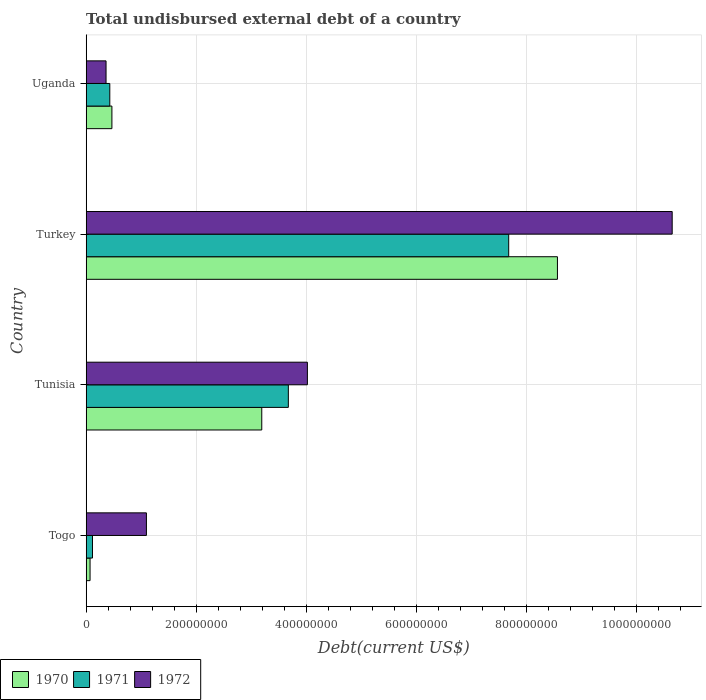How many groups of bars are there?
Keep it short and to the point. 4. Are the number of bars per tick equal to the number of legend labels?
Offer a terse response. Yes. Are the number of bars on each tick of the Y-axis equal?
Offer a very short reply. Yes. How many bars are there on the 3rd tick from the bottom?
Offer a very short reply. 3. What is the label of the 4th group of bars from the top?
Ensure brevity in your answer.  Togo. In how many cases, is the number of bars for a given country not equal to the number of legend labels?
Your answer should be compact. 0. What is the total undisbursed external debt in 1970 in Togo?
Your answer should be compact. 7.03e+06. Across all countries, what is the maximum total undisbursed external debt in 1971?
Your response must be concise. 7.68e+08. Across all countries, what is the minimum total undisbursed external debt in 1970?
Offer a very short reply. 7.03e+06. In which country was the total undisbursed external debt in 1972 minimum?
Keep it short and to the point. Uganda. What is the total total undisbursed external debt in 1970 in the graph?
Your response must be concise. 1.23e+09. What is the difference between the total undisbursed external debt in 1970 in Togo and that in Turkey?
Ensure brevity in your answer.  -8.50e+08. What is the difference between the total undisbursed external debt in 1971 in Uganda and the total undisbursed external debt in 1970 in Turkey?
Ensure brevity in your answer.  -8.14e+08. What is the average total undisbursed external debt in 1971 per country?
Offer a terse response. 2.98e+08. What is the difference between the total undisbursed external debt in 1970 and total undisbursed external debt in 1972 in Togo?
Give a very brief answer. -1.02e+08. What is the ratio of the total undisbursed external debt in 1971 in Togo to that in Turkey?
Offer a terse response. 0.01. What is the difference between the highest and the second highest total undisbursed external debt in 1970?
Give a very brief answer. 5.38e+08. What is the difference between the highest and the lowest total undisbursed external debt in 1971?
Make the answer very short. 7.57e+08. In how many countries, is the total undisbursed external debt in 1971 greater than the average total undisbursed external debt in 1971 taken over all countries?
Your answer should be compact. 2. What does the 2nd bar from the top in Tunisia represents?
Offer a terse response. 1971. What does the 3rd bar from the bottom in Uganda represents?
Keep it short and to the point. 1972. Are all the bars in the graph horizontal?
Ensure brevity in your answer.  Yes. Does the graph contain grids?
Make the answer very short. Yes. Where does the legend appear in the graph?
Provide a succinct answer. Bottom left. How are the legend labels stacked?
Give a very brief answer. Horizontal. What is the title of the graph?
Your answer should be very brief. Total undisbursed external debt of a country. Does "2015" appear as one of the legend labels in the graph?
Your answer should be compact. No. What is the label or title of the X-axis?
Your answer should be very brief. Debt(current US$). What is the label or title of the Y-axis?
Ensure brevity in your answer.  Country. What is the Debt(current US$) of 1970 in Togo?
Offer a terse response. 7.03e+06. What is the Debt(current US$) of 1971 in Togo?
Your answer should be compact. 1.15e+07. What is the Debt(current US$) in 1972 in Togo?
Provide a short and direct response. 1.10e+08. What is the Debt(current US$) of 1970 in Tunisia?
Ensure brevity in your answer.  3.19e+08. What is the Debt(current US$) of 1971 in Tunisia?
Ensure brevity in your answer.  3.68e+08. What is the Debt(current US$) in 1972 in Tunisia?
Give a very brief answer. 4.02e+08. What is the Debt(current US$) in 1970 in Turkey?
Make the answer very short. 8.57e+08. What is the Debt(current US$) in 1971 in Turkey?
Offer a terse response. 7.68e+08. What is the Debt(current US$) of 1972 in Turkey?
Your response must be concise. 1.07e+09. What is the Debt(current US$) of 1970 in Uganda?
Your response must be concise. 4.68e+07. What is the Debt(current US$) of 1971 in Uganda?
Give a very brief answer. 4.29e+07. What is the Debt(current US$) of 1972 in Uganda?
Offer a terse response. 3.61e+07. Across all countries, what is the maximum Debt(current US$) in 1970?
Offer a terse response. 8.57e+08. Across all countries, what is the maximum Debt(current US$) in 1971?
Provide a succinct answer. 7.68e+08. Across all countries, what is the maximum Debt(current US$) in 1972?
Your answer should be compact. 1.07e+09. Across all countries, what is the minimum Debt(current US$) in 1970?
Make the answer very short. 7.03e+06. Across all countries, what is the minimum Debt(current US$) of 1971?
Offer a terse response. 1.15e+07. Across all countries, what is the minimum Debt(current US$) of 1972?
Give a very brief answer. 3.61e+07. What is the total Debt(current US$) of 1970 in the graph?
Offer a very short reply. 1.23e+09. What is the total Debt(current US$) in 1971 in the graph?
Provide a short and direct response. 1.19e+09. What is the total Debt(current US$) of 1972 in the graph?
Keep it short and to the point. 1.61e+09. What is the difference between the Debt(current US$) of 1970 in Togo and that in Tunisia?
Provide a short and direct response. -3.12e+08. What is the difference between the Debt(current US$) of 1971 in Togo and that in Tunisia?
Give a very brief answer. -3.56e+08. What is the difference between the Debt(current US$) of 1972 in Togo and that in Tunisia?
Keep it short and to the point. -2.93e+08. What is the difference between the Debt(current US$) in 1970 in Togo and that in Turkey?
Your answer should be very brief. -8.50e+08. What is the difference between the Debt(current US$) of 1971 in Togo and that in Turkey?
Provide a succinct answer. -7.57e+08. What is the difference between the Debt(current US$) in 1972 in Togo and that in Turkey?
Offer a very short reply. -9.56e+08. What is the difference between the Debt(current US$) of 1970 in Togo and that in Uganda?
Offer a terse response. -3.97e+07. What is the difference between the Debt(current US$) in 1971 in Togo and that in Uganda?
Provide a short and direct response. -3.15e+07. What is the difference between the Debt(current US$) in 1972 in Togo and that in Uganda?
Offer a terse response. 7.34e+07. What is the difference between the Debt(current US$) in 1970 in Tunisia and that in Turkey?
Your response must be concise. -5.38e+08. What is the difference between the Debt(current US$) in 1971 in Tunisia and that in Turkey?
Provide a succinct answer. -4.01e+08. What is the difference between the Debt(current US$) in 1972 in Tunisia and that in Turkey?
Make the answer very short. -6.63e+08. What is the difference between the Debt(current US$) of 1970 in Tunisia and that in Uganda?
Ensure brevity in your answer.  2.72e+08. What is the difference between the Debt(current US$) of 1971 in Tunisia and that in Uganda?
Offer a very short reply. 3.25e+08. What is the difference between the Debt(current US$) of 1972 in Tunisia and that in Uganda?
Keep it short and to the point. 3.66e+08. What is the difference between the Debt(current US$) of 1970 in Turkey and that in Uganda?
Provide a succinct answer. 8.10e+08. What is the difference between the Debt(current US$) in 1971 in Turkey and that in Uganda?
Offer a terse response. 7.25e+08. What is the difference between the Debt(current US$) of 1972 in Turkey and that in Uganda?
Make the answer very short. 1.03e+09. What is the difference between the Debt(current US$) of 1970 in Togo and the Debt(current US$) of 1971 in Tunisia?
Your response must be concise. -3.61e+08. What is the difference between the Debt(current US$) of 1970 in Togo and the Debt(current US$) of 1972 in Tunisia?
Your answer should be very brief. -3.95e+08. What is the difference between the Debt(current US$) in 1971 in Togo and the Debt(current US$) in 1972 in Tunisia?
Give a very brief answer. -3.91e+08. What is the difference between the Debt(current US$) of 1970 in Togo and the Debt(current US$) of 1971 in Turkey?
Keep it short and to the point. -7.61e+08. What is the difference between the Debt(current US$) of 1970 in Togo and the Debt(current US$) of 1972 in Turkey?
Your answer should be compact. -1.06e+09. What is the difference between the Debt(current US$) of 1971 in Togo and the Debt(current US$) of 1972 in Turkey?
Ensure brevity in your answer.  -1.05e+09. What is the difference between the Debt(current US$) of 1970 in Togo and the Debt(current US$) of 1971 in Uganda?
Provide a short and direct response. -3.59e+07. What is the difference between the Debt(current US$) in 1970 in Togo and the Debt(current US$) in 1972 in Uganda?
Your answer should be compact. -2.91e+07. What is the difference between the Debt(current US$) of 1971 in Togo and the Debt(current US$) of 1972 in Uganda?
Your answer should be very brief. -2.46e+07. What is the difference between the Debt(current US$) of 1970 in Tunisia and the Debt(current US$) of 1971 in Turkey?
Your response must be concise. -4.49e+08. What is the difference between the Debt(current US$) of 1970 in Tunisia and the Debt(current US$) of 1972 in Turkey?
Ensure brevity in your answer.  -7.46e+08. What is the difference between the Debt(current US$) in 1971 in Tunisia and the Debt(current US$) in 1972 in Turkey?
Give a very brief answer. -6.98e+08. What is the difference between the Debt(current US$) in 1970 in Tunisia and the Debt(current US$) in 1971 in Uganda?
Give a very brief answer. 2.76e+08. What is the difference between the Debt(current US$) of 1970 in Tunisia and the Debt(current US$) of 1972 in Uganda?
Offer a very short reply. 2.83e+08. What is the difference between the Debt(current US$) of 1971 in Tunisia and the Debt(current US$) of 1972 in Uganda?
Your response must be concise. 3.31e+08. What is the difference between the Debt(current US$) of 1970 in Turkey and the Debt(current US$) of 1971 in Uganda?
Offer a very short reply. 8.14e+08. What is the difference between the Debt(current US$) of 1970 in Turkey and the Debt(current US$) of 1972 in Uganda?
Make the answer very short. 8.21e+08. What is the difference between the Debt(current US$) of 1971 in Turkey and the Debt(current US$) of 1972 in Uganda?
Give a very brief answer. 7.32e+08. What is the average Debt(current US$) of 1970 per country?
Offer a terse response. 3.07e+08. What is the average Debt(current US$) in 1971 per country?
Give a very brief answer. 2.98e+08. What is the average Debt(current US$) of 1972 per country?
Your answer should be compact. 4.03e+08. What is the difference between the Debt(current US$) in 1970 and Debt(current US$) in 1971 in Togo?
Provide a succinct answer. -4.42e+06. What is the difference between the Debt(current US$) in 1970 and Debt(current US$) in 1972 in Togo?
Offer a very short reply. -1.02e+08. What is the difference between the Debt(current US$) in 1971 and Debt(current US$) in 1972 in Togo?
Keep it short and to the point. -9.81e+07. What is the difference between the Debt(current US$) of 1970 and Debt(current US$) of 1971 in Tunisia?
Provide a short and direct response. -4.83e+07. What is the difference between the Debt(current US$) of 1970 and Debt(current US$) of 1972 in Tunisia?
Provide a short and direct response. -8.30e+07. What is the difference between the Debt(current US$) of 1971 and Debt(current US$) of 1972 in Tunisia?
Provide a short and direct response. -3.46e+07. What is the difference between the Debt(current US$) of 1970 and Debt(current US$) of 1971 in Turkey?
Your answer should be very brief. 8.86e+07. What is the difference between the Debt(current US$) in 1970 and Debt(current US$) in 1972 in Turkey?
Make the answer very short. -2.09e+08. What is the difference between the Debt(current US$) of 1971 and Debt(current US$) of 1972 in Turkey?
Give a very brief answer. -2.97e+08. What is the difference between the Debt(current US$) in 1970 and Debt(current US$) in 1971 in Uganda?
Make the answer very short. 3.85e+06. What is the difference between the Debt(current US$) of 1970 and Debt(current US$) of 1972 in Uganda?
Your response must be concise. 1.07e+07. What is the difference between the Debt(current US$) of 1971 and Debt(current US$) of 1972 in Uganda?
Your response must be concise. 6.81e+06. What is the ratio of the Debt(current US$) in 1970 in Togo to that in Tunisia?
Offer a terse response. 0.02. What is the ratio of the Debt(current US$) in 1971 in Togo to that in Tunisia?
Ensure brevity in your answer.  0.03. What is the ratio of the Debt(current US$) of 1972 in Togo to that in Tunisia?
Your answer should be very brief. 0.27. What is the ratio of the Debt(current US$) in 1970 in Togo to that in Turkey?
Provide a short and direct response. 0.01. What is the ratio of the Debt(current US$) of 1971 in Togo to that in Turkey?
Offer a terse response. 0.01. What is the ratio of the Debt(current US$) of 1972 in Togo to that in Turkey?
Your answer should be compact. 0.1. What is the ratio of the Debt(current US$) of 1970 in Togo to that in Uganda?
Provide a short and direct response. 0.15. What is the ratio of the Debt(current US$) in 1971 in Togo to that in Uganda?
Your answer should be compact. 0.27. What is the ratio of the Debt(current US$) in 1972 in Togo to that in Uganda?
Provide a short and direct response. 3.03. What is the ratio of the Debt(current US$) of 1970 in Tunisia to that in Turkey?
Your answer should be very brief. 0.37. What is the ratio of the Debt(current US$) in 1971 in Tunisia to that in Turkey?
Provide a succinct answer. 0.48. What is the ratio of the Debt(current US$) in 1972 in Tunisia to that in Turkey?
Make the answer very short. 0.38. What is the ratio of the Debt(current US$) in 1970 in Tunisia to that in Uganda?
Make the answer very short. 6.83. What is the ratio of the Debt(current US$) of 1971 in Tunisia to that in Uganda?
Provide a short and direct response. 8.57. What is the ratio of the Debt(current US$) in 1972 in Tunisia to that in Uganda?
Give a very brief answer. 11.14. What is the ratio of the Debt(current US$) of 1970 in Turkey to that in Uganda?
Make the answer very short. 18.32. What is the ratio of the Debt(current US$) in 1971 in Turkey to that in Uganda?
Ensure brevity in your answer.  17.9. What is the ratio of the Debt(current US$) in 1972 in Turkey to that in Uganda?
Your answer should be compact. 29.51. What is the difference between the highest and the second highest Debt(current US$) of 1970?
Keep it short and to the point. 5.38e+08. What is the difference between the highest and the second highest Debt(current US$) of 1971?
Provide a short and direct response. 4.01e+08. What is the difference between the highest and the second highest Debt(current US$) in 1972?
Ensure brevity in your answer.  6.63e+08. What is the difference between the highest and the lowest Debt(current US$) of 1970?
Keep it short and to the point. 8.50e+08. What is the difference between the highest and the lowest Debt(current US$) in 1971?
Offer a very short reply. 7.57e+08. What is the difference between the highest and the lowest Debt(current US$) of 1972?
Offer a terse response. 1.03e+09. 